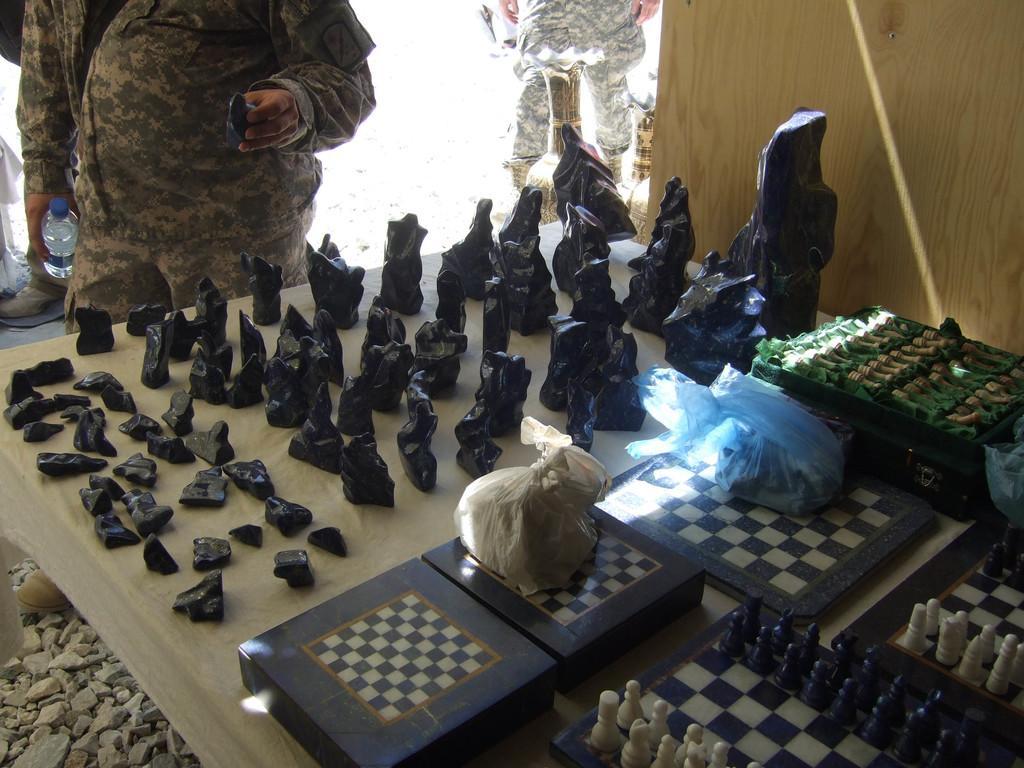In one or two sentences, can you explain what this image depicts? In this image we can see a table. On the table there are different sizes of stones, chess boards, chess coins and polythene covers. Beside the table we can see persons standing. 